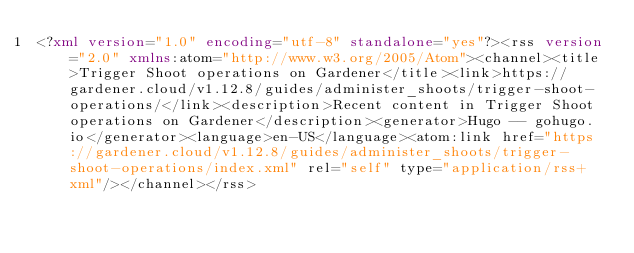<code> <loc_0><loc_0><loc_500><loc_500><_XML_><?xml version="1.0" encoding="utf-8" standalone="yes"?><rss version="2.0" xmlns:atom="http://www.w3.org/2005/Atom"><channel><title>Trigger Shoot operations on Gardener</title><link>https://gardener.cloud/v1.12.8/guides/administer_shoots/trigger-shoot-operations/</link><description>Recent content in Trigger Shoot operations on Gardener</description><generator>Hugo -- gohugo.io</generator><language>en-US</language><atom:link href="https://gardener.cloud/v1.12.8/guides/administer_shoots/trigger-shoot-operations/index.xml" rel="self" type="application/rss+xml"/></channel></rss></code> 